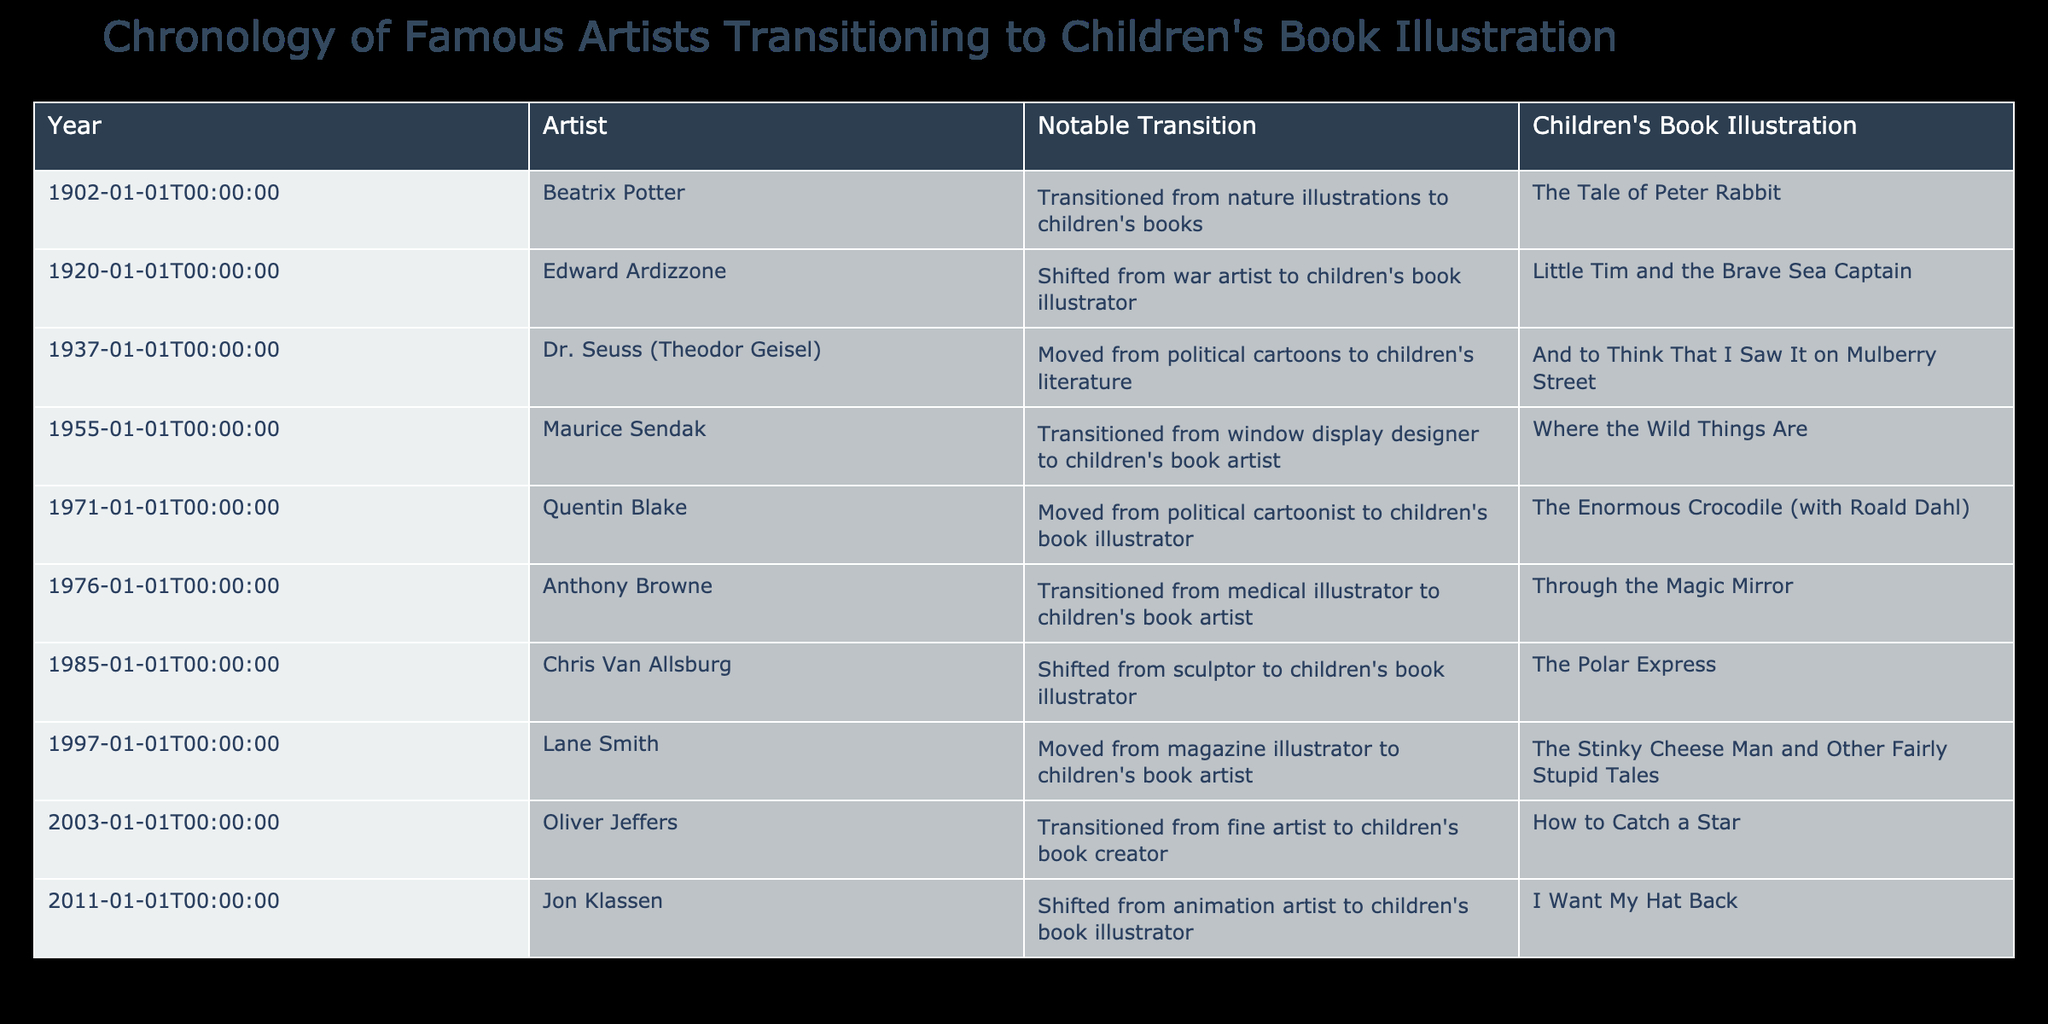What year did Beatrix Potter transition into children's book illustration? The table lists Beatrix Potter's transition year as 1902, where she moved from creating nature illustrations to children's books.
Answer: 1902 Which artist made the transition from being a war artist to a children's book illustrator? According to the table, Edward Ardizzone is noted for shifting from a war artist to a children's book illustrator in 1920.
Answer: Edward Ardizzone How many artists transitioned into children's book illustration after 1975? The table includes three artists who transitioned after 1975: Anthony Browne in 1976, Chris Van Allsburg in 1985, and Lane Smith in 1997. Therefore, the total count is 3.
Answer: 3 Did Oliver Jeffers start his career as a fine artist before illustrating children's books? The table indicates that Oliver Jeffers transitioned from being a fine artist to a children's book creator in 2003, confirming that he did start as a fine artist.
Answer: Yes Which artist illustrated "Where the Wild Things Are," and what was his previous occupation? The table states that Maurice Sendak, who illustrated "Where the Wild Things Are," transitioned from being a window display designer to a children's book artist in 1955.
Answer: Maurice Sendak; window display designer How many notable transitions listed in the table occurred in the 20th century? Looking through the table, the notable transitions that occurred in the 20th century are Beatrix Potter (1902), Edward Ardizzone (1920), Dr. Seuss (1937), Maurice Sendak (1955), Quentin Blake (1971), Anthony Browne (1976), and Chris Van Allsburg (1985). This accounts for a total of 7 transitions.
Answer: 7 Which artist made the earliest transition into children's book illustration, and what was their notable work? Beatrix Potter is the artist with the earliest transition in 1902, and her notable work is "The Tale of Peter Rabbit."
Answer: Beatrix Potter; The Tale of Peter Rabbit What was the notable work of the artist who transitioned in 2011? The table shows that Jon Klassen transitioned in 2011, and his notable children's book is "I Want My Hat Back."
Answer: I Want My Hat Back 